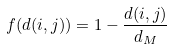<formula> <loc_0><loc_0><loc_500><loc_500>f ( d ( i , j ) ) = 1 - \frac { d ( i , j ) } { d _ { M } }</formula> 